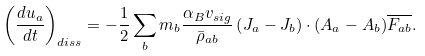<formula> <loc_0><loc_0><loc_500><loc_500>\left ( \frac { d u _ { a } } { d t } \right ) _ { d i s s } = - \frac { 1 } { 2 } \sum _ { b } m _ { b } \frac { \alpha _ { B } v _ { s i g } } { \bar { \rho } _ { a b } } \left ( { J } _ { a } - { J } _ { b } \right ) \cdot ( { A } _ { a } - { A } _ { b } ) \overline { F _ { a b } } .</formula> 